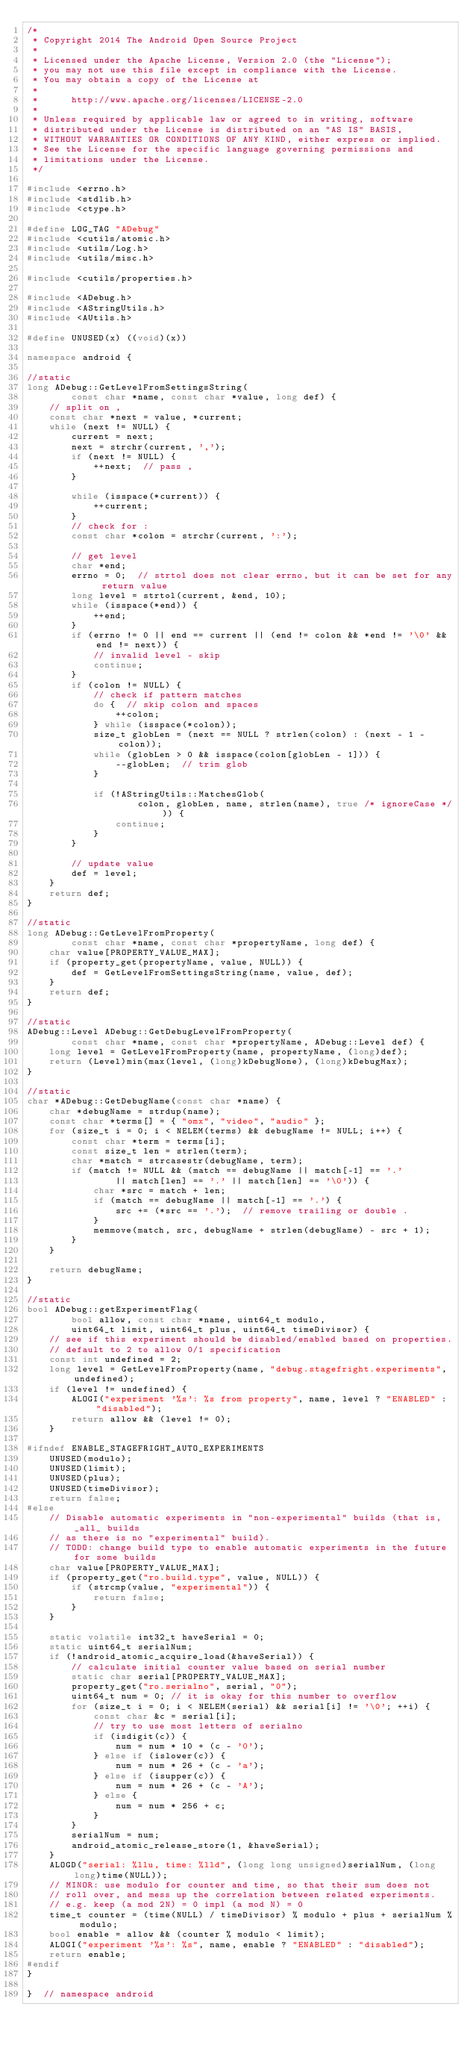Convert code to text. <code><loc_0><loc_0><loc_500><loc_500><_C++_>/*
 * Copyright 2014 The Android Open Source Project
 *
 * Licensed under the Apache License, Version 2.0 (the "License");
 * you may not use this file except in compliance with the License.
 * You may obtain a copy of the License at
 *
 *      http://www.apache.org/licenses/LICENSE-2.0
 *
 * Unless required by applicable law or agreed to in writing, software
 * distributed under the License is distributed on an "AS IS" BASIS,
 * WITHOUT WARRANTIES OR CONDITIONS OF ANY KIND, either express or implied.
 * See the License for the specific language governing permissions and
 * limitations under the License.
 */

#include <errno.h>
#include <stdlib.h>
#include <ctype.h>

#define LOG_TAG "ADebug"
#include <cutils/atomic.h>
#include <utils/Log.h>
#include <utils/misc.h>

#include <cutils/properties.h>

#include <ADebug.h>
#include <AStringUtils.h>
#include <AUtils.h>

#define UNUSED(x) ((void)(x))

namespace android {

//static
long ADebug::GetLevelFromSettingsString(
        const char *name, const char *value, long def) {
    // split on ,
    const char *next = value, *current;
    while (next != NULL) {
        current = next;
        next = strchr(current, ',');
        if (next != NULL) {
            ++next;  // pass ,
        }

        while (isspace(*current)) {
            ++current;
        }
        // check for :
        const char *colon = strchr(current, ':');

        // get level
        char *end;
        errno = 0;  // strtol does not clear errno, but it can be set for any return value
        long level = strtol(current, &end, 10);
        while (isspace(*end)) {
            ++end;
        }
        if (errno != 0 || end == current || (end != colon && *end != '\0' && end != next)) {
            // invalid level - skip
            continue;
        }
        if (colon != NULL) {
            // check if pattern matches
            do {  // skip colon and spaces
                ++colon;
            } while (isspace(*colon));
            size_t globLen = (next == NULL ? strlen(colon) : (next - 1 - colon));
            while (globLen > 0 && isspace(colon[globLen - 1])) {
                --globLen;  // trim glob
            }

            if (!AStringUtils::MatchesGlob(
                    colon, globLen, name, strlen(name), true /* ignoreCase */)) {
                continue;
            }
        }

        // update value
        def = level;
    }
    return def;
}

//static
long ADebug::GetLevelFromProperty(
        const char *name, const char *propertyName, long def) {
    char value[PROPERTY_VALUE_MAX];
    if (property_get(propertyName, value, NULL)) {
        def = GetLevelFromSettingsString(name, value, def);
    }
    return def;
}

//static
ADebug::Level ADebug::GetDebugLevelFromProperty(
        const char *name, const char *propertyName, ADebug::Level def) {
    long level = GetLevelFromProperty(name, propertyName, (long)def);
    return (Level)min(max(level, (long)kDebugNone), (long)kDebugMax);
}

//static
char *ADebug::GetDebugName(const char *name) {
    char *debugName = strdup(name);
    const char *terms[] = { "omx", "video", "audio" };
    for (size_t i = 0; i < NELEM(terms) && debugName != NULL; i++) {
        const char *term = terms[i];
        const size_t len = strlen(term);
        char *match = strcasestr(debugName, term);
        if (match != NULL && (match == debugName || match[-1] == '.'
                || match[len] == '.' || match[len] == '\0')) {
            char *src = match + len;
            if (match == debugName || match[-1] == '.') {
                src += (*src == '.');  // remove trailing or double .
            }
            memmove(match, src, debugName + strlen(debugName) - src + 1);
        }
    }

    return debugName;
}

//static
bool ADebug::getExperimentFlag(
        bool allow, const char *name, uint64_t modulo,
        uint64_t limit, uint64_t plus, uint64_t timeDivisor) {
    // see if this experiment should be disabled/enabled based on properties.
    // default to 2 to allow 0/1 specification
    const int undefined = 2;
    long level = GetLevelFromProperty(name, "debug.stagefright.experiments", undefined);
    if (level != undefined) {
        ALOGI("experiment '%s': %s from property", name, level ? "ENABLED" : "disabled");
        return allow && (level != 0);
    }

#ifndef ENABLE_STAGEFRIGHT_AUTO_EXPERIMENTS
    UNUSED(modulo);
    UNUSED(limit);
    UNUSED(plus);
    UNUSED(timeDivisor);
    return false;
#else
    // Disable automatic experiments in "non-experimental" builds (that is, _all_ builds
    // as there is no "experimental" build).
    // TODO: change build type to enable automatic experiments in the future for some builds
    char value[PROPERTY_VALUE_MAX];
    if (property_get("ro.build.type", value, NULL)) {
        if (strcmp(value, "experimental")) {
            return false;
        }
    }

    static volatile int32_t haveSerial = 0;
    static uint64_t serialNum;
    if (!android_atomic_acquire_load(&haveSerial)) {
        // calculate initial counter value based on serial number
        static char serial[PROPERTY_VALUE_MAX];
        property_get("ro.serialno", serial, "0");
        uint64_t num = 0; // it is okay for this number to overflow
        for (size_t i = 0; i < NELEM(serial) && serial[i] != '\0'; ++i) {
            const char &c = serial[i];
            // try to use most letters of serialno
            if (isdigit(c)) {
                num = num * 10 + (c - '0');
            } else if (islower(c)) {
                num = num * 26 + (c - 'a');
            } else if (isupper(c)) {
                num = num * 26 + (c - 'A');
            } else {
                num = num * 256 + c;
            }
        }
        serialNum = num;
        android_atomic_release_store(1, &haveSerial);
    }
    ALOGD("serial: %llu, time: %lld", (long long unsigned)serialNum, (long long)time(NULL));
    // MINOR: use modulo for counter and time, so that their sum does not
    // roll over, and mess up the correlation between related experiments.
    // e.g. keep (a mod 2N) = 0 impl (a mod N) = 0
    time_t counter = (time(NULL) / timeDivisor) % modulo + plus + serialNum % modulo;
    bool enable = allow && (counter % modulo < limit);
    ALOGI("experiment '%s': %s", name, enable ? "ENABLED" : "disabled");
    return enable;
#endif
}

}  // namespace android

</code> 